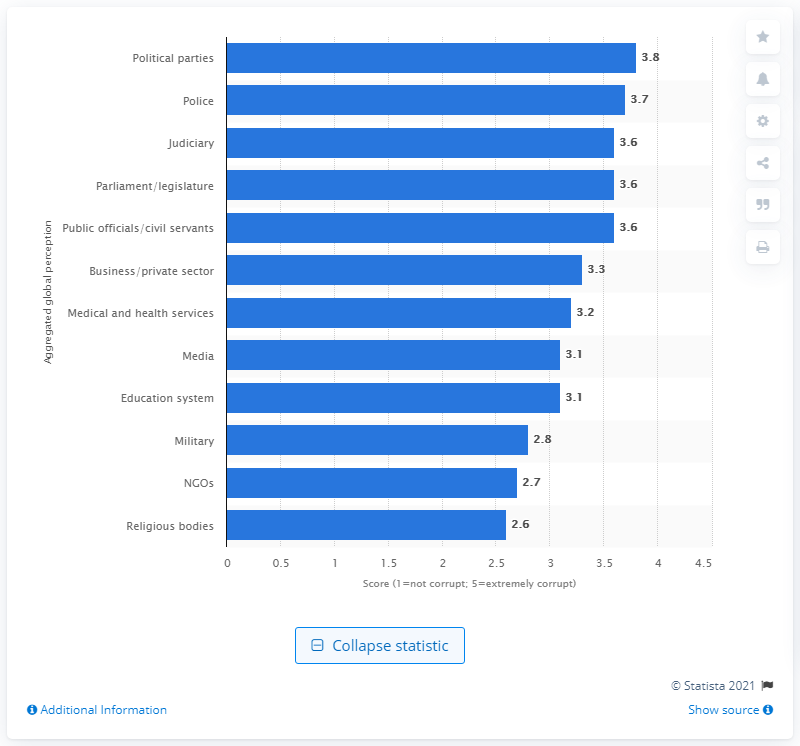Specify some key components in this picture. The political parties received a combined score of 3.8 on a scale of 1 to 5. 